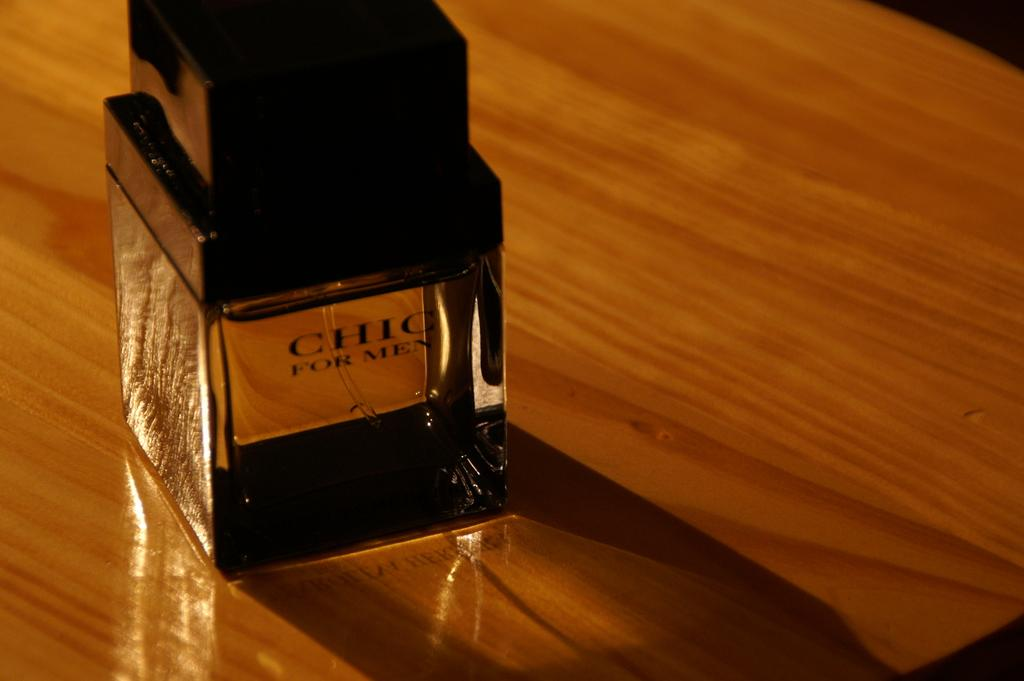<image>
Render a clear and concise summary of the photo. A spray bottle of cologne called CHIC FOR MEN 